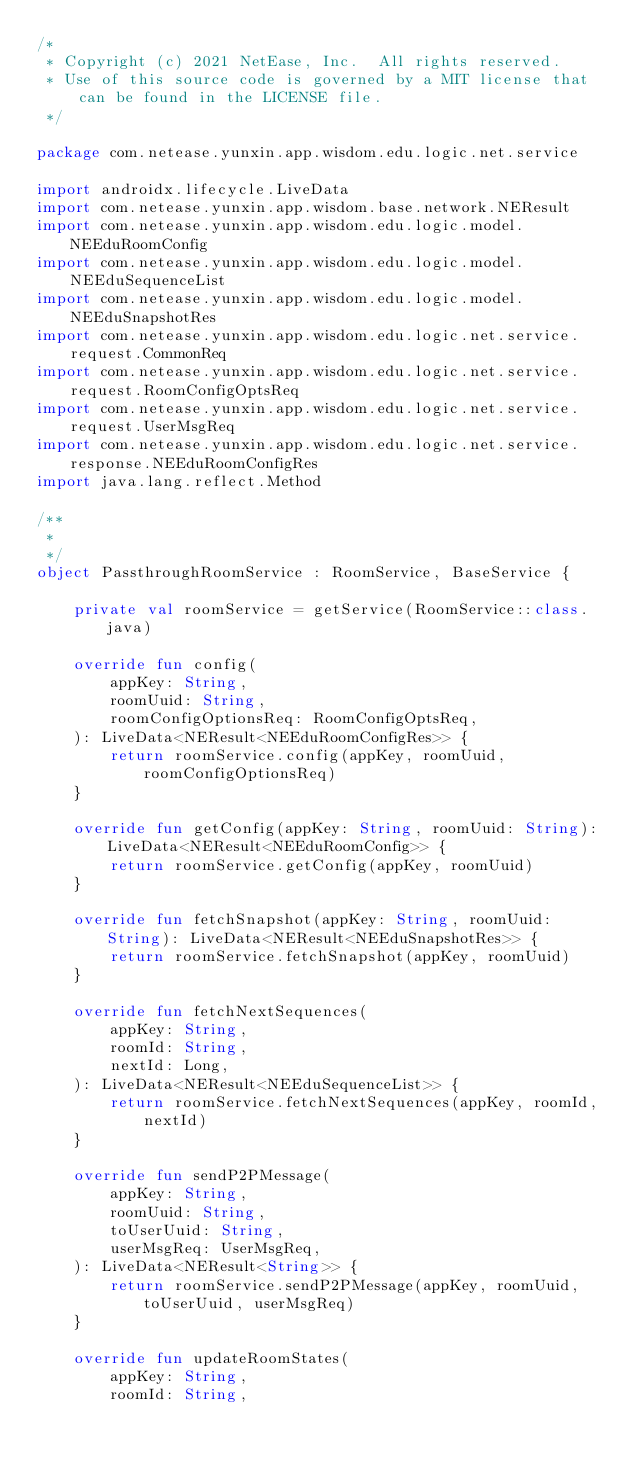<code> <loc_0><loc_0><loc_500><loc_500><_Kotlin_>/*
 * Copyright (c) 2021 NetEase, Inc.  All rights reserved.
 * Use of this source code is governed by a MIT license that can be found in the LICENSE file.
 */

package com.netease.yunxin.app.wisdom.edu.logic.net.service

import androidx.lifecycle.LiveData
import com.netease.yunxin.app.wisdom.base.network.NEResult
import com.netease.yunxin.app.wisdom.edu.logic.model.NEEduRoomConfig
import com.netease.yunxin.app.wisdom.edu.logic.model.NEEduSequenceList
import com.netease.yunxin.app.wisdom.edu.logic.model.NEEduSnapshotRes
import com.netease.yunxin.app.wisdom.edu.logic.net.service.request.CommonReq
import com.netease.yunxin.app.wisdom.edu.logic.net.service.request.RoomConfigOptsReq
import com.netease.yunxin.app.wisdom.edu.logic.net.service.request.UserMsgReq
import com.netease.yunxin.app.wisdom.edu.logic.net.service.response.NEEduRoomConfigRes
import java.lang.reflect.Method

/**
 * 
 */
object PassthroughRoomService : RoomService, BaseService {

    private val roomService = getService(RoomService::class.java)

    override fun config(
        appKey: String,
        roomUuid: String,
        roomConfigOptionsReq: RoomConfigOptsReq,
    ): LiveData<NEResult<NEEduRoomConfigRes>> {
        return roomService.config(appKey, roomUuid, roomConfigOptionsReq)
    }

    override fun getConfig(appKey: String, roomUuid: String): LiveData<NEResult<NEEduRoomConfig>> {
        return roomService.getConfig(appKey, roomUuid)
    }

    override fun fetchSnapshot(appKey: String, roomUuid: String): LiveData<NEResult<NEEduSnapshotRes>> {
        return roomService.fetchSnapshot(appKey, roomUuid)
    }

    override fun fetchNextSequences(
        appKey: String,
        roomId: String,
        nextId: Long,
    ): LiveData<NEResult<NEEduSequenceList>> {
        return roomService.fetchNextSequences(appKey, roomId, nextId)
    }

    override fun sendP2PMessage(
        appKey: String,
        roomUuid: String,
        toUserUuid: String,
        userMsgReq: UserMsgReq,
    ): LiveData<NEResult<String>> {
        return roomService.sendP2PMessage(appKey, roomUuid, toUserUuid, userMsgReq)
    }

    override fun updateRoomStates(
        appKey: String,
        roomId: String,</code> 